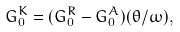<formula> <loc_0><loc_0><loc_500><loc_500>G _ { 0 } ^ { K } = ( G _ { 0 } ^ { R } - G _ { 0 } ^ { A } ) ( \theta / \omega ) ,</formula> 